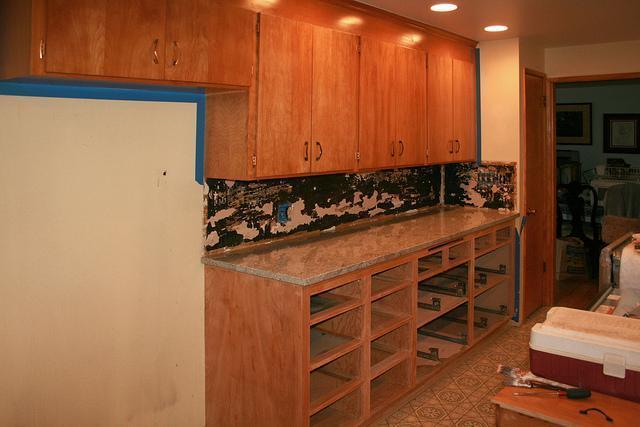How many cabinet locks are there?
Give a very brief answer. 0. How many people are standing in the truck?
Give a very brief answer. 0. 